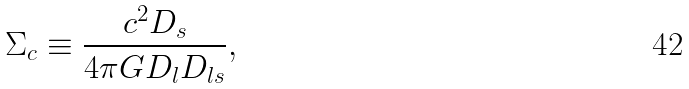Convert formula to latex. <formula><loc_0><loc_0><loc_500><loc_500>\Sigma _ { c } \equiv \frac { c ^ { 2 } D _ { s } } { 4 \pi G D _ { l } D _ { l s } } ,</formula> 